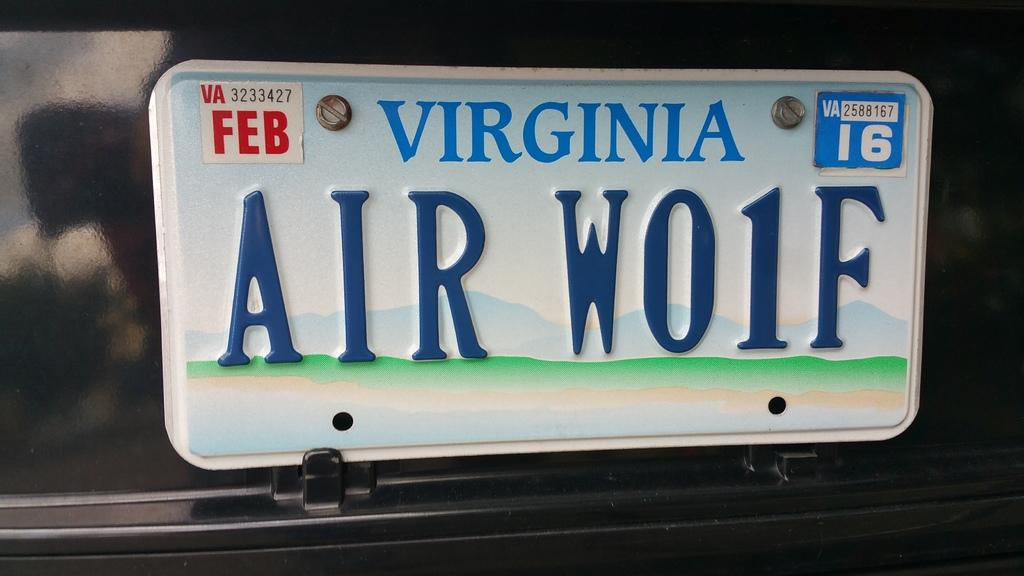<image>
Describe the image concisely. A Virginia license plate says AIR W01F on it. 